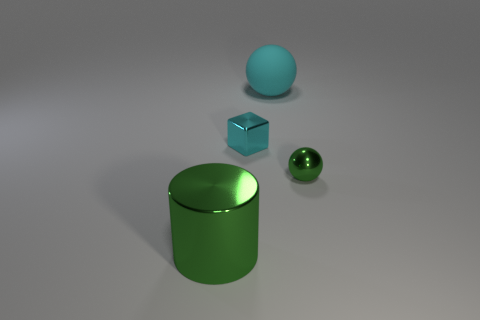What is the color of the small thing that is made of the same material as the tiny cyan block?
Ensure brevity in your answer.  Green. Are there any cylinders that are right of the big thing that is in front of the large sphere?
Ensure brevity in your answer.  No. How many other things are there of the same shape as the big metal object?
Keep it short and to the point. 0. Does the small shiny thing that is to the left of the cyan ball have the same shape as the large thing that is behind the big green metal cylinder?
Your response must be concise. No. How many metal cylinders are to the left of the cyan object that is on the right side of the cyan cube in front of the cyan ball?
Your answer should be compact. 1. What is the color of the rubber sphere?
Offer a terse response. Cyan. How many other things are the same size as the green cylinder?
Offer a very short reply. 1. What is the material of the large object that is the same shape as the small green shiny thing?
Offer a very short reply. Rubber. What is the material of the big object that is to the left of the sphere that is behind the green metallic thing that is on the right side of the cyan matte object?
Your answer should be compact. Metal. What size is the cyan block that is the same material as the tiny green object?
Your answer should be compact. Small. 